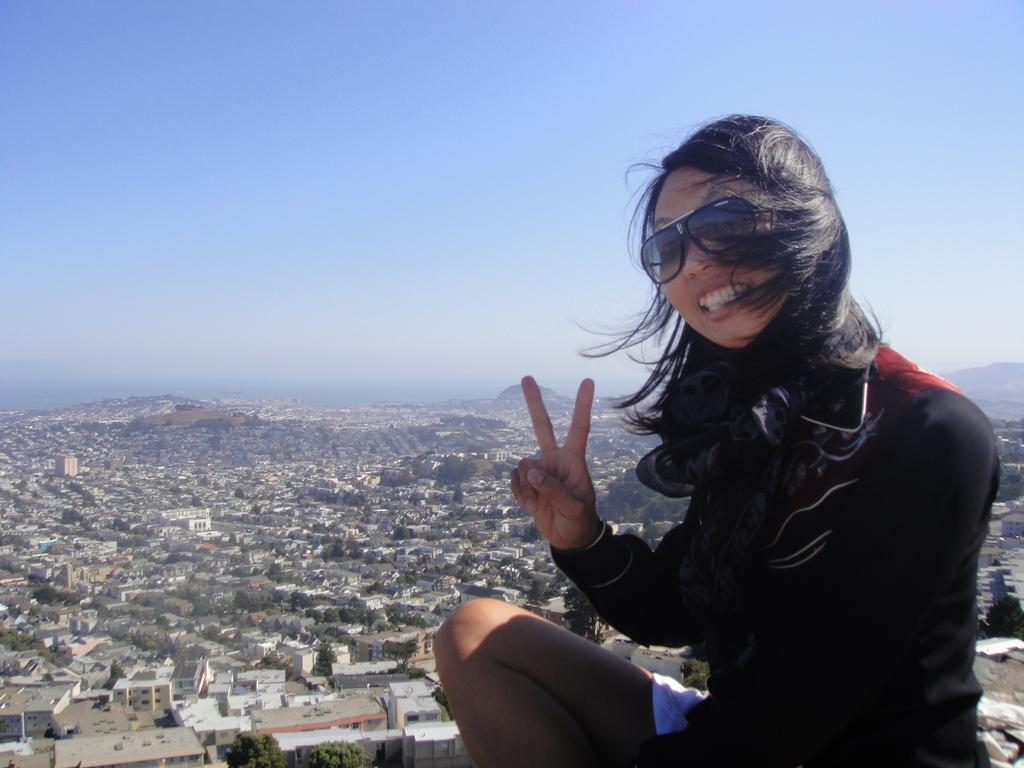Who is on the right side of the image? There is a woman on the right side of the image. What can be seen in the background of the image? There are buildings, trees, and hills in the background of the image. What is visible at the top of the image? The sky is visible at the top of the image. Reasoning: Let' Let's think step by step in order to produce the conversation. We start by identifying the main subject in the image, which is the woman on the right side. Then, we expand the conversation to include the background elements, such as buildings, trees, and hills. Finally, we mention the sky visible at the top of the image. Each question is designed to elicit a specific detail about the image that is known from the provided facts. Absurd Question/Answer: What type of nail is being used to hold the pickle in the image? There is no nail or pickle present in the image. 